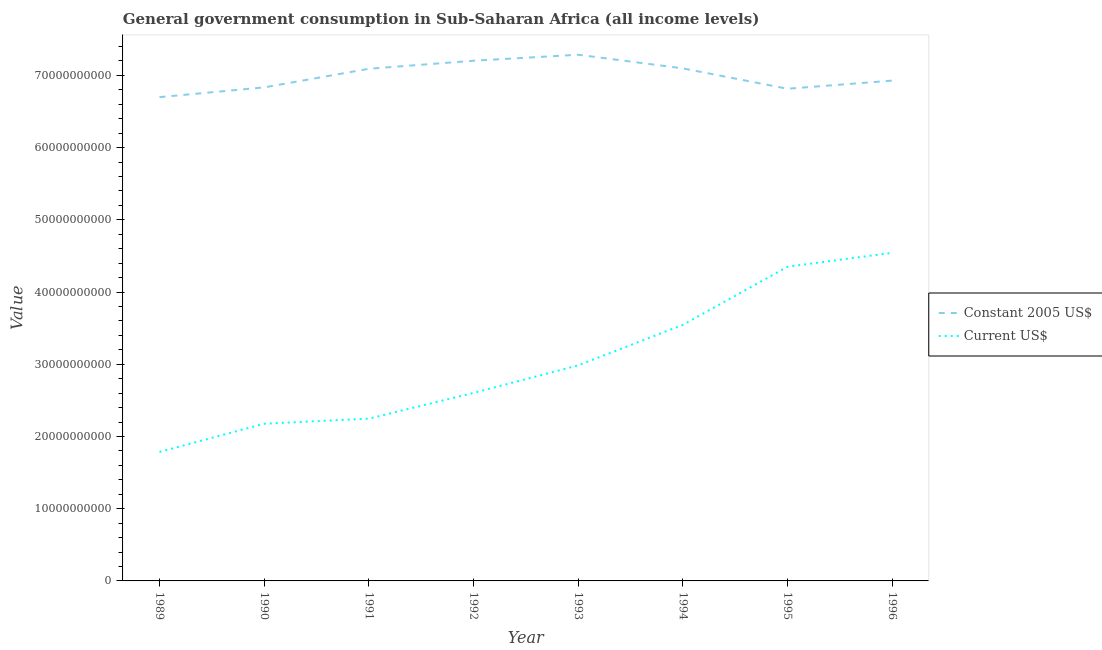How many different coloured lines are there?
Give a very brief answer. 2. What is the value consumed in constant 2005 us$ in 1996?
Ensure brevity in your answer.  6.93e+1. Across all years, what is the maximum value consumed in current us$?
Offer a very short reply. 4.54e+1. Across all years, what is the minimum value consumed in current us$?
Ensure brevity in your answer.  1.79e+1. In which year was the value consumed in constant 2005 us$ minimum?
Provide a succinct answer. 1989. What is the total value consumed in current us$ in the graph?
Your answer should be very brief. 2.42e+11. What is the difference between the value consumed in constant 2005 us$ in 1993 and that in 1996?
Give a very brief answer. 3.58e+09. What is the difference between the value consumed in current us$ in 1993 and the value consumed in constant 2005 us$ in 1994?
Offer a terse response. -4.11e+1. What is the average value consumed in current us$ per year?
Ensure brevity in your answer.  3.03e+1. In the year 1989, what is the difference between the value consumed in current us$ and value consumed in constant 2005 us$?
Provide a succinct answer. -4.91e+1. In how many years, is the value consumed in constant 2005 us$ greater than 62000000000?
Provide a short and direct response. 8. What is the ratio of the value consumed in constant 2005 us$ in 1992 to that in 1994?
Your response must be concise. 1.01. Is the value consumed in current us$ in 1992 less than that in 1994?
Give a very brief answer. Yes. What is the difference between the highest and the second highest value consumed in current us$?
Offer a very short reply. 1.93e+09. What is the difference between the highest and the lowest value consumed in constant 2005 us$?
Your response must be concise. 5.87e+09. Does the value consumed in current us$ monotonically increase over the years?
Provide a short and direct response. Yes. Does the graph contain grids?
Offer a very short reply. No. How many legend labels are there?
Make the answer very short. 2. How are the legend labels stacked?
Keep it short and to the point. Vertical. What is the title of the graph?
Your response must be concise. General government consumption in Sub-Saharan Africa (all income levels). What is the label or title of the X-axis?
Your response must be concise. Year. What is the label or title of the Y-axis?
Your answer should be very brief. Value. What is the Value of Constant 2005 US$ in 1989?
Offer a very short reply. 6.70e+1. What is the Value of Current US$ in 1989?
Your answer should be very brief. 1.79e+1. What is the Value of Constant 2005 US$ in 1990?
Ensure brevity in your answer.  6.83e+1. What is the Value of Current US$ in 1990?
Offer a very short reply. 2.18e+1. What is the Value in Constant 2005 US$ in 1991?
Your response must be concise. 7.09e+1. What is the Value of Current US$ in 1991?
Offer a terse response. 2.25e+1. What is the Value in Constant 2005 US$ in 1992?
Provide a short and direct response. 7.20e+1. What is the Value in Current US$ in 1992?
Provide a succinct answer. 2.60e+1. What is the Value of Constant 2005 US$ in 1993?
Provide a succinct answer. 7.29e+1. What is the Value in Current US$ in 1993?
Provide a succinct answer. 2.98e+1. What is the Value of Constant 2005 US$ in 1994?
Ensure brevity in your answer.  7.10e+1. What is the Value in Current US$ in 1994?
Your answer should be very brief. 3.55e+1. What is the Value in Constant 2005 US$ in 1995?
Your answer should be compact. 6.81e+1. What is the Value in Current US$ in 1995?
Offer a terse response. 4.35e+1. What is the Value of Constant 2005 US$ in 1996?
Your response must be concise. 6.93e+1. What is the Value of Current US$ in 1996?
Offer a terse response. 4.54e+1. Across all years, what is the maximum Value in Constant 2005 US$?
Provide a short and direct response. 7.29e+1. Across all years, what is the maximum Value of Current US$?
Your response must be concise. 4.54e+1. Across all years, what is the minimum Value in Constant 2005 US$?
Give a very brief answer. 6.70e+1. Across all years, what is the minimum Value of Current US$?
Keep it short and to the point. 1.79e+1. What is the total Value in Constant 2005 US$ in the graph?
Give a very brief answer. 5.59e+11. What is the total Value of Current US$ in the graph?
Your answer should be compact. 2.42e+11. What is the difference between the Value of Constant 2005 US$ in 1989 and that in 1990?
Make the answer very short. -1.35e+09. What is the difference between the Value of Current US$ in 1989 and that in 1990?
Offer a terse response. -3.91e+09. What is the difference between the Value of Constant 2005 US$ in 1989 and that in 1991?
Keep it short and to the point. -3.93e+09. What is the difference between the Value in Current US$ in 1989 and that in 1991?
Make the answer very short. -4.61e+09. What is the difference between the Value of Constant 2005 US$ in 1989 and that in 1992?
Give a very brief answer. -5.04e+09. What is the difference between the Value in Current US$ in 1989 and that in 1992?
Your answer should be compact. -8.17e+09. What is the difference between the Value of Constant 2005 US$ in 1989 and that in 1993?
Your response must be concise. -5.87e+09. What is the difference between the Value in Current US$ in 1989 and that in 1993?
Keep it short and to the point. -1.20e+1. What is the difference between the Value in Constant 2005 US$ in 1989 and that in 1994?
Make the answer very short. -3.98e+09. What is the difference between the Value in Current US$ in 1989 and that in 1994?
Your answer should be compact. -1.76e+1. What is the difference between the Value of Constant 2005 US$ in 1989 and that in 1995?
Provide a short and direct response. -1.16e+09. What is the difference between the Value of Current US$ in 1989 and that in 1995?
Ensure brevity in your answer.  -2.56e+1. What is the difference between the Value in Constant 2005 US$ in 1989 and that in 1996?
Provide a short and direct response. -2.29e+09. What is the difference between the Value of Current US$ in 1989 and that in 1996?
Offer a very short reply. -2.76e+1. What is the difference between the Value of Constant 2005 US$ in 1990 and that in 1991?
Ensure brevity in your answer.  -2.58e+09. What is the difference between the Value in Current US$ in 1990 and that in 1991?
Give a very brief answer. -7.02e+08. What is the difference between the Value in Constant 2005 US$ in 1990 and that in 1992?
Give a very brief answer. -3.69e+09. What is the difference between the Value of Current US$ in 1990 and that in 1992?
Keep it short and to the point. -4.26e+09. What is the difference between the Value of Constant 2005 US$ in 1990 and that in 1993?
Your answer should be compact. -4.52e+09. What is the difference between the Value of Current US$ in 1990 and that in 1993?
Make the answer very short. -8.08e+09. What is the difference between the Value of Constant 2005 US$ in 1990 and that in 1994?
Provide a succinct answer. -2.63e+09. What is the difference between the Value in Current US$ in 1990 and that in 1994?
Provide a short and direct response. -1.37e+1. What is the difference between the Value in Constant 2005 US$ in 1990 and that in 1995?
Your response must be concise. 1.87e+08. What is the difference between the Value in Current US$ in 1990 and that in 1995?
Your answer should be compact. -2.17e+1. What is the difference between the Value in Constant 2005 US$ in 1990 and that in 1996?
Offer a very short reply. -9.37e+08. What is the difference between the Value of Current US$ in 1990 and that in 1996?
Offer a terse response. -2.37e+1. What is the difference between the Value in Constant 2005 US$ in 1991 and that in 1992?
Your answer should be very brief. -1.11e+09. What is the difference between the Value of Current US$ in 1991 and that in 1992?
Give a very brief answer. -3.56e+09. What is the difference between the Value of Constant 2005 US$ in 1991 and that in 1993?
Ensure brevity in your answer.  -1.94e+09. What is the difference between the Value of Current US$ in 1991 and that in 1993?
Offer a terse response. -7.38e+09. What is the difference between the Value of Constant 2005 US$ in 1991 and that in 1994?
Provide a short and direct response. -5.48e+07. What is the difference between the Value of Current US$ in 1991 and that in 1994?
Keep it short and to the point. -1.30e+1. What is the difference between the Value of Constant 2005 US$ in 1991 and that in 1995?
Your response must be concise. 2.76e+09. What is the difference between the Value in Current US$ in 1991 and that in 1995?
Your answer should be very brief. -2.10e+1. What is the difference between the Value in Constant 2005 US$ in 1991 and that in 1996?
Offer a terse response. 1.64e+09. What is the difference between the Value of Current US$ in 1991 and that in 1996?
Give a very brief answer. -2.30e+1. What is the difference between the Value in Constant 2005 US$ in 1992 and that in 1993?
Give a very brief answer. -8.31e+08. What is the difference between the Value of Current US$ in 1992 and that in 1993?
Your answer should be very brief. -3.81e+09. What is the difference between the Value of Constant 2005 US$ in 1992 and that in 1994?
Give a very brief answer. 1.06e+09. What is the difference between the Value in Current US$ in 1992 and that in 1994?
Your response must be concise. -9.42e+09. What is the difference between the Value in Constant 2005 US$ in 1992 and that in 1995?
Provide a succinct answer. 3.88e+09. What is the difference between the Value in Current US$ in 1992 and that in 1995?
Provide a short and direct response. -1.75e+1. What is the difference between the Value of Constant 2005 US$ in 1992 and that in 1996?
Offer a terse response. 2.75e+09. What is the difference between the Value of Current US$ in 1992 and that in 1996?
Your answer should be very brief. -1.94e+1. What is the difference between the Value of Constant 2005 US$ in 1993 and that in 1994?
Your response must be concise. 1.89e+09. What is the difference between the Value in Current US$ in 1993 and that in 1994?
Provide a short and direct response. -5.61e+09. What is the difference between the Value of Constant 2005 US$ in 1993 and that in 1995?
Your answer should be very brief. 4.71e+09. What is the difference between the Value of Current US$ in 1993 and that in 1995?
Make the answer very short. -1.37e+1. What is the difference between the Value in Constant 2005 US$ in 1993 and that in 1996?
Give a very brief answer. 3.58e+09. What is the difference between the Value of Current US$ in 1993 and that in 1996?
Make the answer very short. -1.56e+1. What is the difference between the Value of Constant 2005 US$ in 1994 and that in 1995?
Your response must be concise. 2.82e+09. What is the difference between the Value in Current US$ in 1994 and that in 1995?
Your answer should be very brief. -8.04e+09. What is the difference between the Value of Constant 2005 US$ in 1994 and that in 1996?
Make the answer very short. 1.70e+09. What is the difference between the Value of Current US$ in 1994 and that in 1996?
Provide a succinct answer. -9.97e+09. What is the difference between the Value in Constant 2005 US$ in 1995 and that in 1996?
Provide a short and direct response. -1.12e+09. What is the difference between the Value in Current US$ in 1995 and that in 1996?
Give a very brief answer. -1.93e+09. What is the difference between the Value of Constant 2005 US$ in 1989 and the Value of Current US$ in 1990?
Make the answer very short. 4.52e+1. What is the difference between the Value in Constant 2005 US$ in 1989 and the Value in Current US$ in 1991?
Offer a very short reply. 4.45e+1. What is the difference between the Value of Constant 2005 US$ in 1989 and the Value of Current US$ in 1992?
Provide a succinct answer. 4.10e+1. What is the difference between the Value of Constant 2005 US$ in 1989 and the Value of Current US$ in 1993?
Your response must be concise. 3.71e+1. What is the difference between the Value in Constant 2005 US$ in 1989 and the Value in Current US$ in 1994?
Your answer should be very brief. 3.15e+1. What is the difference between the Value of Constant 2005 US$ in 1989 and the Value of Current US$ in 1995?
Offer a terse response. 2.35e+1. What is the difference between the Value of Constant 2005 US$ in 1989 and the Value of Current US$ in 1996?
Provide a short and direct response. 2.16e+1. What is the difference between the Value in Constant 2005 US$ in 1990 and the Value in Current US$ in 1991?
Your answer should be very brief. 4.59e+1. What is the difference between the Value of Constant 2005 US$ in 1990 and the Value of Current US$ in 1992?
Offer a very short reply. 4.23e+1. What is the difference between the Value of Constant 2005 US$ in 1990 and the Value of Current US$ in 1993?
Make the answer very short. 3.85e+1. What is the difference between the Value in Constant 2005 US$ in 1990 and the Value in Current US$ in 1994?
Your answer should be compact. 3.29e+1. What is the difference between the Value of Constant 2005 US$ in 1990 and the Value of Current US$ in 1995?
Provide a short and direct response. 2.48e+1. What is the difference between the Value of Constant 2005 US$ in 1990 and the Value of Current US$ in 1996?
Provide a short and direct response. 2.29e+1. What is the difference between the Value in Constant 2005 US$ in 1991 and the Value in Current US$ in 1992?
Provide a succinct answer. 4.49e+1. What is the difference between the Value of Constant 2005 US$ in 1991 and the Value of Current US$ in 1993?
Keep it short and to the point. 4.11e+1. What is the difference between the Value of Constant 2005 US$ in 1991 and the Value of Current US$ in 1994?
Your response must be concise. 3.55e+1. What is the difference between the Value in Constant 2005 US$ in 1991 and the Value in Current US$ in 1995?
Offer a terse response. 2.74e+1. What is the difference between the Value in Constant 2005 US$ in 1991 and the Value in Current US$ in 1996?
Provide a short and direct response. 2.55e+1. What is the difference between the Value in Constant 2005 US$ in 1992 and the Value in Current US$ in 1993?
Offer a very short reply. 4.22e+1. What is the difference between the Value of Constant 2005 US$ in 1992 and the Value of Current US$ in 1994?
Ensure brevity in your answer.  3.66e+1. What is the difference between the Value of Constant 2005 US$ in 1992 and the Value of Current US$ in 1995?
Provide a short and direct response. 2.85e+1. What is the difference between the Value in Constant 2005 US$ in 1992 and the Value in Current US$ in 1996?
Offer a very short reply. 2.66e+1. What is the difference between the Value in Constant 2005 US$ in 1993 and the Value in Current US$ in 1994?
Give a very brief answer. 3.74e+1. What is the difference between the Value of Constant 2005 US$ in 1993 and the Value of Current US$ in 1995?
Give a very brief answer. 2.94e+1. What is the difference between the Value in Constant 2005 US$ in 1993 and the Value in Current US$ in 1996?
Make the answer very short. 2.74e+1. What is the difference between the Value of Constant 2005 US$ in 1994 and the Value of Current US$ in 1995?
Offer a very short reply. 2.75e+1. What is the difference between the Value in Constant 2005 US$ in 1994 and the Value in Current US$ in 1996?
Ensure brevity in your answer.  2.55e+1. What is the difference between the Value of Constant 2005 US$ in 1995 and the Value of Current US$ in 1996?
Provide a short and direct response. 2.27e+1. What is the average Value in Constant 2005 US$ per year?
Offer a terse response. 6.99e+1. What is the average Value of Current US$ per year?
Give a very brief answer. 3.03e+1. In the year 1989, what is the difference between the Value in Constant 2005 US$ and Value in Current US$?
Offer a terse response. 4.91e+1. In the year 1990, what is the difference between the Value in Constant 2005 US$ and Value in Current US$?
Offer a very short reply. 4.66e+1. In the year 1991, what is the difference between the Value in Constant 2005 US$ and Value in Current US$?
Your answer should be very brief. 4.84e+1. In the year 1992, what is the difference between the Value of Constant 2005 US$ and Value of Current US$?
Your answer should be compact. 4.60e+1. In the year 1993, what is the difference between the Value of Constant 2005 US$ and Value of Current US$?
Provide a succinct answer. 4.30e+1. In the year 1994, what is the difference between the Value in Constant 2005 US$ and Value in Current US$?
Your response must be concise. 3.55e+1. In the year 1995, what is the difference between the Value in Constant 2005 US$ and Value in Current US$?
Provide a succinct answer. 2.46e+1. In the year 1996, what is the difference between the Value of Constant 2005 US$ and Value of Current US$?
Keep it short and to the point. 2.38e+1. What is the ratio of the Value of Constant 2005 US$ in 1989 to that in 1990?
Your answer should be compact. 0.98. What is the ratio of the Value of Current US$ in 1989 to that in 1990?
Offer a very short reply. 0.82. What is the ratio of the Value of Constant 2005 US$ in 1989 to that in 1991?
Your answer should be very brief. 0.94. What is the ratio of the Value in Current US$ in 1989 to that in 1991?
Make the answer very short. 0.79. What is the ratio of the Value of Constant 2005 US$ in 1989 to that in 1992?
Give a very brief answer. 0.93. What is the ratio of the Value of Current US$ in 1989 to that in 1992?
Give a very brief answer. 0.69. What is the ratio of the Value of Constant 2005 US$ in 1989 to that in 1993?
Provide a succinct answer. 0.92. What is the ratio of the Value of Current US$ in 1989 to that in 1993?
Offer a terse response. 0.6. What is the ratio of the Value in Constant 2005 US$ in 1989 to that in 1994?
Your answer should be compact. 0.94. What is the ratio of the Value in Current US$ in 1989 to that in 1994?
Ensure brevity in your answer.  0.5. What is the ratio of the Value of Constant 2005 US$ in 1989 to that in 1995?
Ensure brevity in your answer.  0.98. What is the ratio of the Value of Current US$ in 1989 to that in 1995?
Your answer should be very brief. 0.41. What is the ratio of the Value in Current US$ in 1989 to that in 1996?
Your response must be concise. 0.39. What is the ratio of the Value in Constant 2005 US$ in 1990 to that in 1991?
Ensure brevity in your answer.  0.96. What is the ratio of the Value in Current US$ in 1990 to that in 1991?
Provide a short and direct response. 0.97. What is the ratio of the Value of Constant 2005 US$ in 1990 to that in 1992?
Make the answer very short. 0.95. What is the ratio of the Value of Current US$ in 1990 to that in 1992?
Your answer should be compact. 0.84. What is the ratio of the Value in Constant 2005 US$ in 1990 to that in 1993?
Your response must be concise. 0.94. What is the ratio of the Value of Current US$ in 1990 to that in 1993?
Ensure brevity in your answer.  0.73. What is the ratio of the Value of Constant 2005 US$ in 1990 to that in 1994?
Offer a terse response. 0.96. What is the ratio of the Value of Current US$ in 1990 to that in 1994?
Provide a short and direct response. 0.61. What is the ratio of the Value in Constant 2005 US$ in 1990 to that in 1995?
Provide a short and direct response. 1. What is the ratio of the Value of Current US$ in 1990 to that in 1995?
Provide a short and direct response. 0.5. What is the ratio of the Value of Constant 2005 US$ in 1990 to that in 1996?
Give a very brief answer. 0.99. What is the ratio of the Value of Current US$ in 1990 to that in 1996?
Your response must be concise. 0.48. What is the ratio of the Value of Constant 2005 US$ in 1991 to that in 1992?
Offer a terse response. 0.98. What is the ratio of the Value of Current US$ in 1991 to that in 1992?
Your answer should be compact. 0.86. What is the ratio of the Value of Constant 2005 US$ in 1991 to that in 1993?
Ensure brevity in your answer.  0.97. What is the ratio of the Value of Current US$ in 1991 to that in 1993?
Make the answer very short. 0.75. What is the ratio of the Value in Current US$ in 1991 to that in 1994?
Your answer should be very brief. 0.63. What is the ratio of the Value of Constant 2005 US$ in 1991 to that in 1995?
Provide a succinct answer. 1.04. What is the ratio of the Value of Current US$ in 1991 to that in 1995?
Your answer should be compact. 0.52. What is the ratio of the Value of Constant 2005 US$ in 1991 to that in 1996?
Ensure brevity in your answer.  1.02. What is the ratio of the Value in Current US$ in 1991 to that in 1996?
Give a very brief answer. 0.49. What is the ratio of the Value in Constant 2005 US$ in 1992 to that in 1993?
Your answer should be compact. 0.99. What is the ratio of the Value in Current US$ in 1992 to that in 1993?
Provide a succinct answer. 0.87. What is the ratio of the Value of Constant 2005 US$ in 1992 to that in 1994?
Keep it short and to the point. 1.01. What is the ratio of the Value in Current US$ in 1992 to that in 1994?
Ensure brevity in your answer.  0.73. What is the ratio of the Value of Constant 2005 US$ in 1992 to that in 1995?
Your response must be concise. 1.06. What is the ratio of the Value of Current US$ in 1992 to that in 1995?
Provide a succinct answer. 0.6. What is the ratio of the Value of Constant 2005 US$ in 1992 to that in 1996?
Your answer should be very brief. 1.04. What is the ratio of the Value in Current US$ in 1992 to that in 1996?
Offer a very short reply. 0.57. What is the ratio of the Value of Constant 2005 US$ in 1993 to that in 1994?
Make the answer very short. 1.03. What is the ratio of the Value of Current US$ in 1993 to that in 1994?
Ensure brevity in your answer.  0.84. What is the ratio of the Value of Constant 2005 US$ in 1993 to that in 1995?
Your answer should be very brief. 1.07. What is the ratio of the Value of Current US$ in 1993 to that in 1995?
Offer a terse response. 0.69. What is the ratio of the Value of Constant 2005 US$ in 1993 to that in 1996?
Offer a terse response. 1.05. What is the ratio of the Value of Current US$ in 1993 to that in 1996?
Provide a short and direct response. 0.66. What is the ratio of the Value of Constant 2005 US$ in 1994 to that in 1995?
Your answer should be compact. 1.04. What is the ratio of the Value in Current US$ in 1994 to that in 1995?
Your response must be concise. 0.82. What is the ratio of the Value of Constant 2005 US$ in 1994 to that in 1996?
Provide a succinct answer. 1.02. What is the ratio of the Value of Current US$ in 1994 to that in 1996?
Give a very brief answer. 0.78. What is the ratio of the Value in Constant 2005 US$ in 1995 to that in 1996?
Keep it short and to the point. 0.98. What is the ratio of the Value in Current US$ in 1995 to that in 1996?
Provide a short and direct response. 0.96. What is the difference between the highest and the second highest Value of Constant 2005 US$?
Ensure brevity in your answer.  8.31e+08. What is the difference between the highest and the second highest Value of Current US$?
Provide a succinct answer. 1.93e+09. What is the difference between the highest and the lowest Value of Constant 2005 US$?
Provide a succinct answer. 5.87e+09. What is the difference between the highest and the lowest Value in Current US$?
Your answer should be very brief. 2.76e+1. 